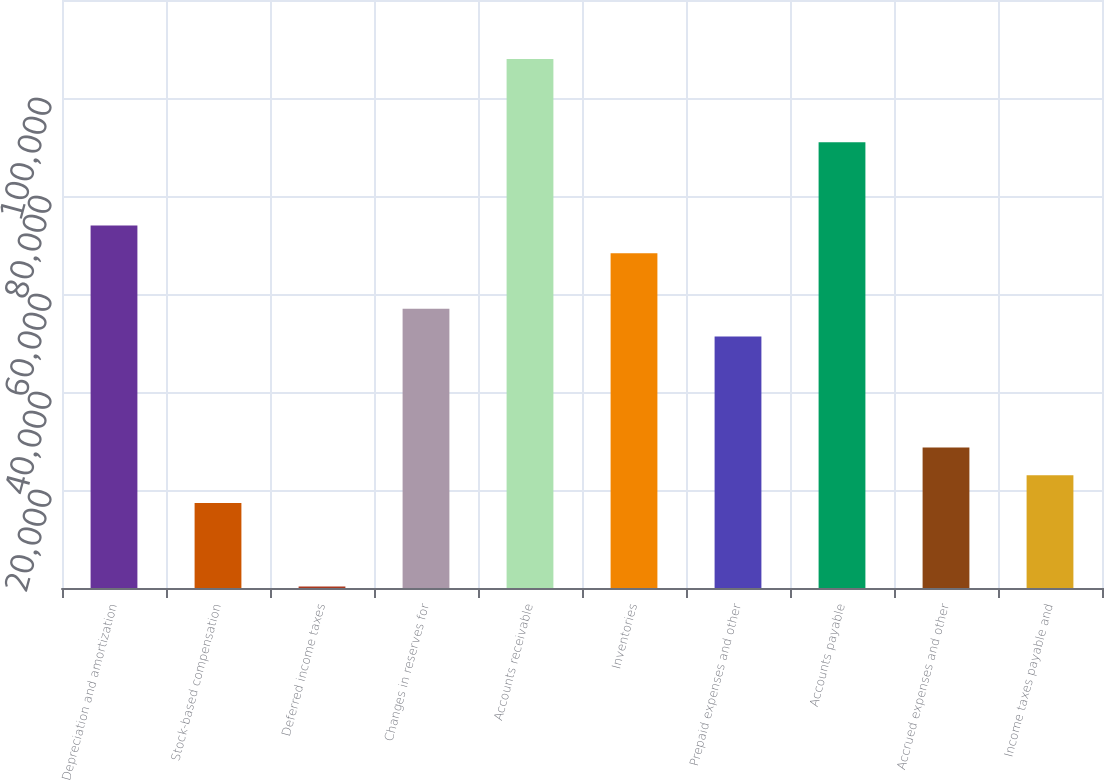<chart> <loc_0><loc_0><loc_500><loc_500><bar_chart><fcel>Depreciation and amortization<fcel>Stock-based compensation<fcel>Deferred income taxes<fcel>Changes in reserves for<fcel>Accounts receivable<fcel>Inventories<fcel>Prepaid expenses and other<fcel>Accounts payable<fcel>Accrued expenses and other<fcel>Income taxes payable and<nl><fcel>73986.4<fcel>17328.4<fcel>331<fcel>56989<fcel>107981<fcel>68320.6<fcel>51323.2<fcel>90983.8<fcel>28660<fcel>22994.2<nl></chart> 